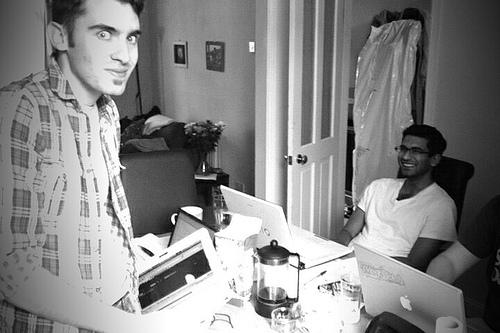How many people are pictured sitting down?
Write a very short answer. 1. Are they in a public place?
Short answer required. No. What brand of laptop is that?
Write a very short answer. Apple. 